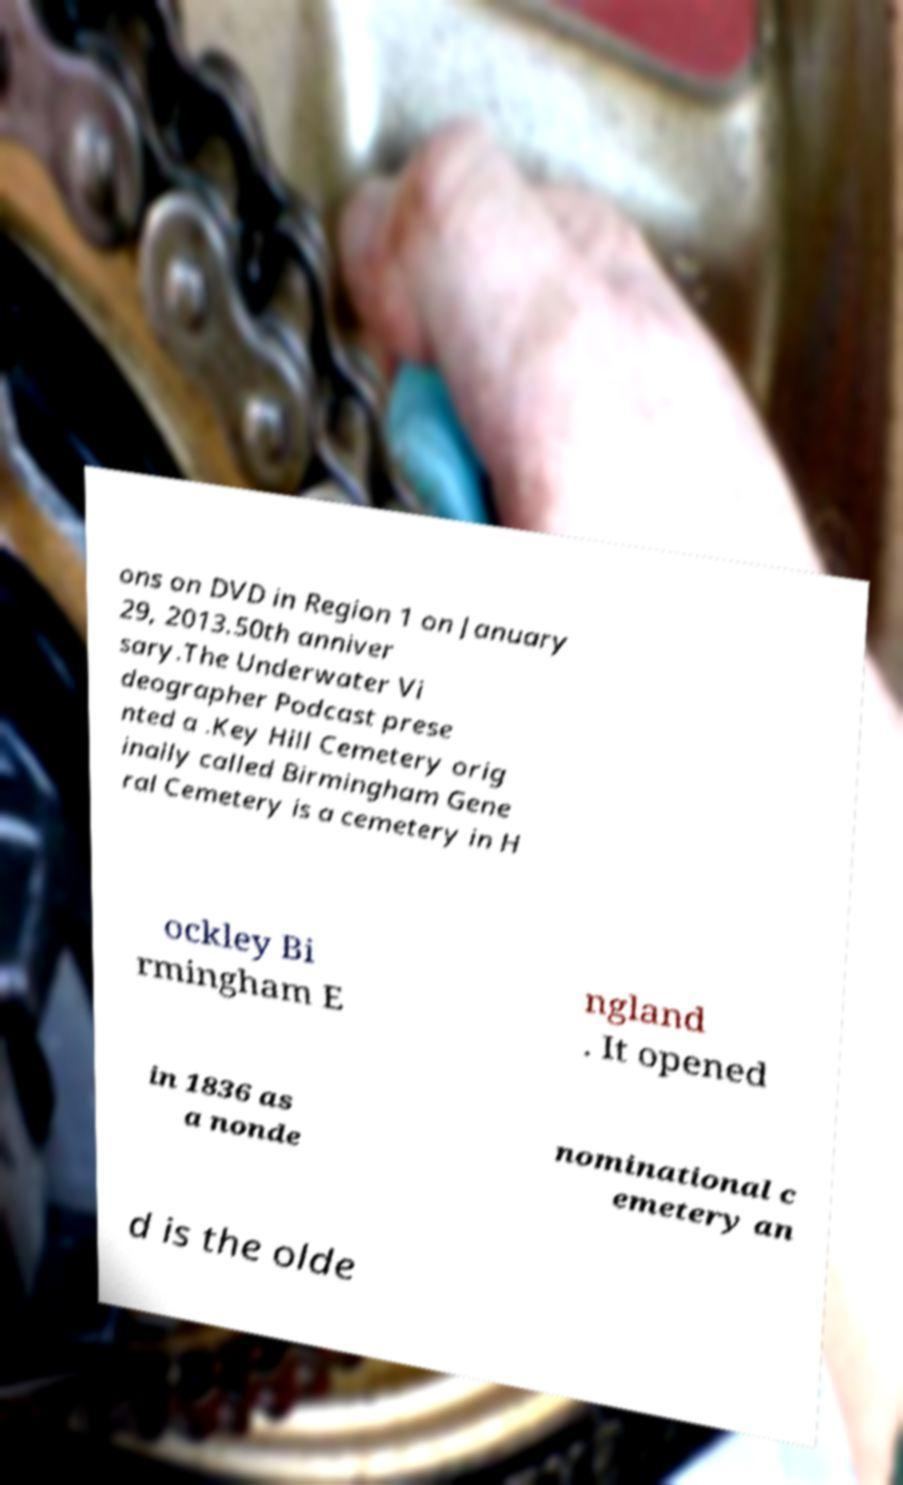For documentation purposes, I need the text within this image transcribed. Could you provide that? ons on DVD in Region 1 on January 29, 2013.50th anniver sary.The Underwater Vi deographer Podcast prese nted a .Key Hill Cemetery orig inally called Birmingham Gene ral Cemetery is a cemetery in H ockley Bi rmingham E ngland . It opened in 1836 as a nonde nominational c emetery an d is the olde 